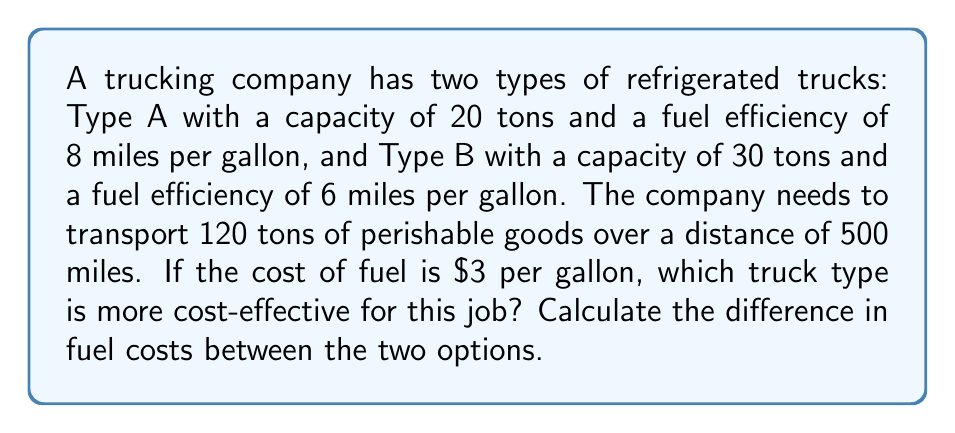Teach me how to tackle this problem. Let's approach this step-by-step:

1) First, calculate the number of trips required for each truck type:
   Type A: $\frac{120 \text{ tons}}{20 \text{ tons/trip}} = 6 \text{ trips}$
   Type B: $\frac{120 \text{ tons}}{30 \text{ tons/trip}} = 4 \text{ trips}$

2) Calculate the total distance traveled for each type:
   Type A: $500 \text{ miles} \times 6 \text{ trips} = 3000 \text{ miles}$
   Type B: $500 \text{ miles} \times 4 \text{ trips} = 2000 \text{ miles}$

3) Calculate the fuel consumption for each type:
   Type A: $\frac{3000 \text{ miles}}{8 \text{ miles/gallon}} = 375 \text{ gallons}$
   Type B: $\frac{2000 \text{ miles}}{6 \text{ miles/gallon}} = 333.33 \text{ gallons}$

4) Calculate the fuel cost for each type:
   Type A: $375 \text{ gallons} \times \$3/\text{gallon} = \$1125$
   Type B: $333.33 \text{ gallons} \times \$3/\text{gallon} = \$1000$

5) Calculate the difference in fuel costs:
   $\$1125 - \$1000 = \$125$

Therefore, Type B trucks are more cost-effective for this job, saving $125 in fuel costs.
Answer: $125 